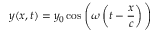Convert formula to latex. <formula><loc_0><loc_0><loc_500><loc_500>y ( x , t ) = y _ { 0 } \cos { \left ( } \omega \left ( t - { \frac { x } { c } } \right ) { \right ) }</formula> 